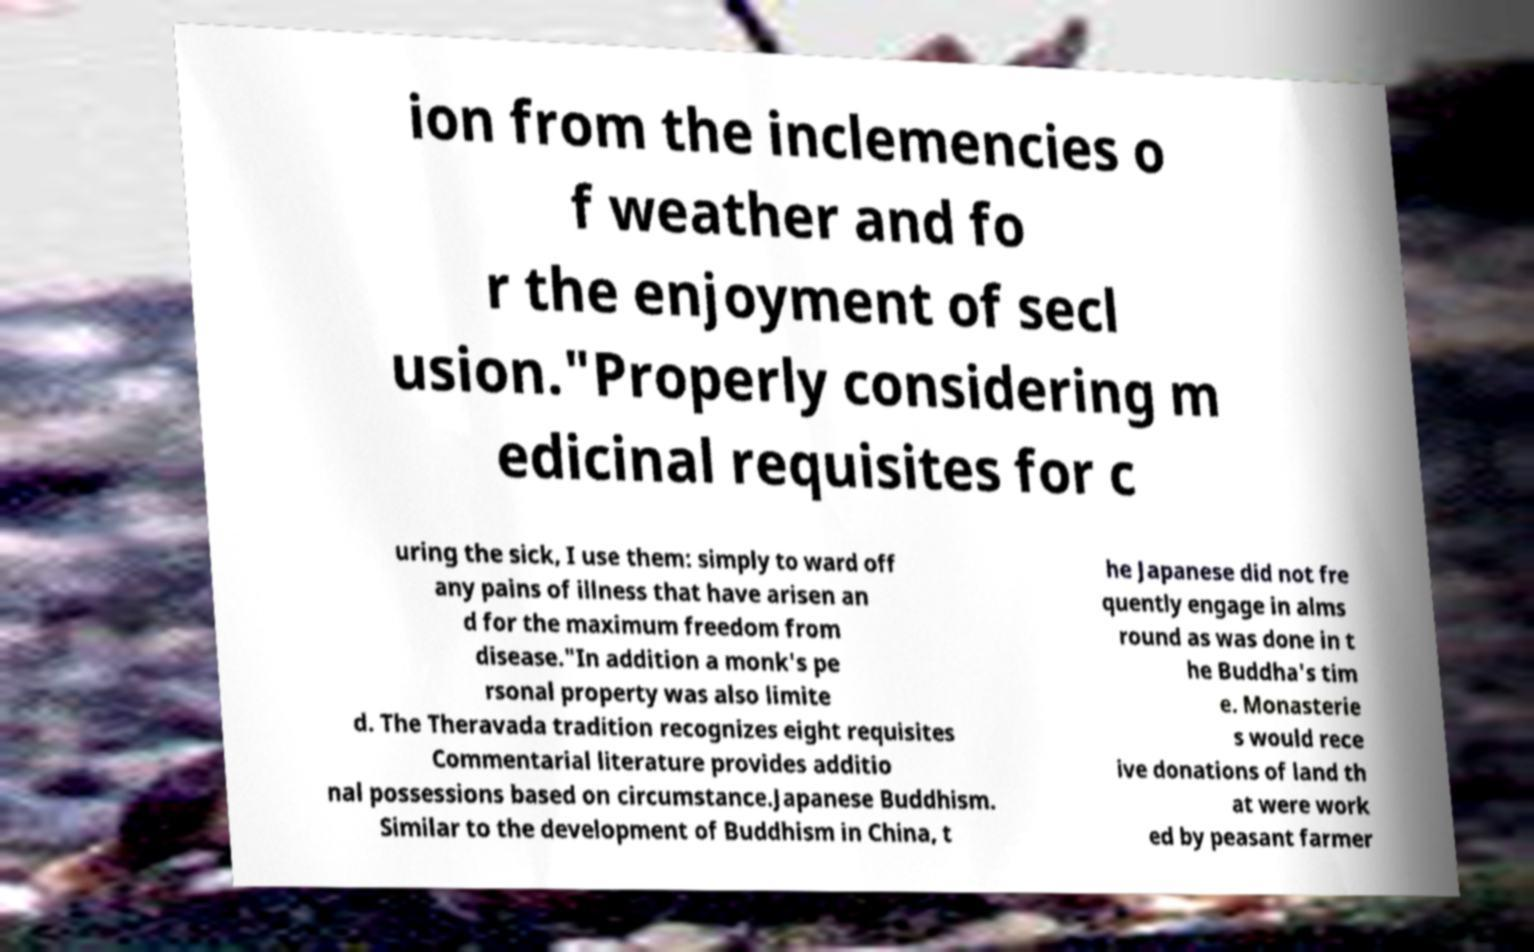Can you read and provide the text displayed in the image?This photo seems to have some interesting text. Can you extract and type it out for me? ion from the inclemencies o f weather and fo r the enjoyment of secl usion."Properly considering m edicinal requisites for c uring the sick, I use them: simply to ward off any pains of illness that have arisen an d for the maximum freedom from disease."In addition a monk's pe rsonal property was also limite d. The Theravada tradition recognizes eight requisites Commentarial literature provides additio nal possessions based on circumstance.Japanese Buddhism. Similar to the development of Buddhism in China, t he Japanese did not fre quently engage in alms round as was done in t he Buddha's tim e. Monasterie s would rece ive donations of land th at were work ed by peasant farmer 